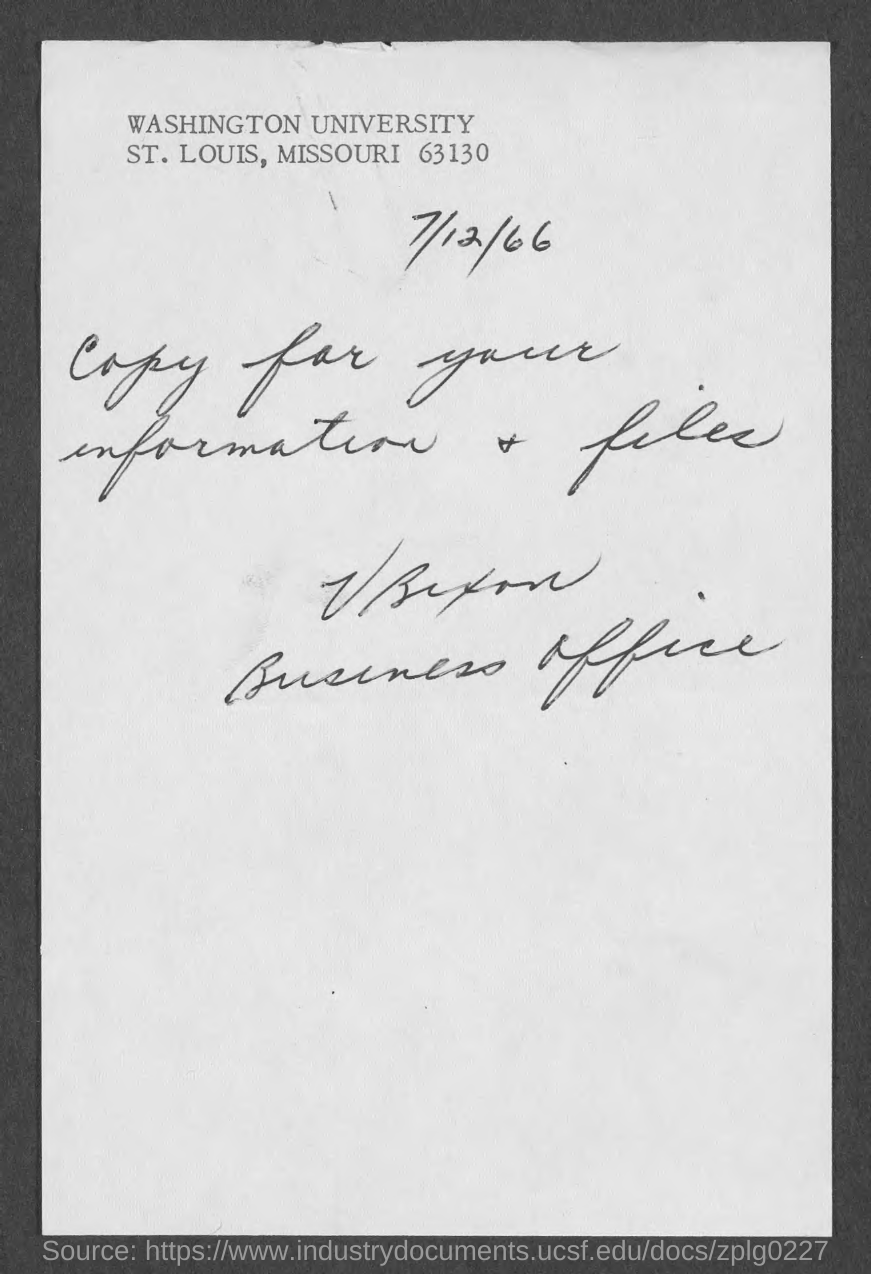Identify some key points in this picture. The document contains the date of July 12, 1966. 